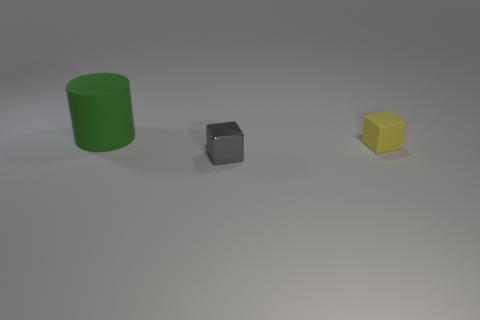Are there more yellow matte blocks behind the big green object than tiny matte things? no 